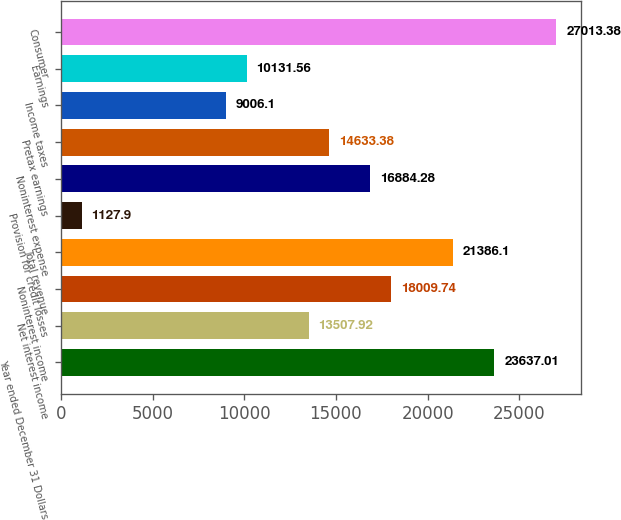Convert chart. <chart><loc_0><loc_0><loc_500><loc_500><bar_chart><fcel>Year ended December 31 Dollars<fcel>Net interest income<fcel>Noninterest income<fcel>Total revenue<fcel>Provision for credit losses<fcel>Noninterest expense<fcel>Pretax earnings<fcel>Income taxes<fcel>Earnings<fcel>Consumer<nl><fcel>23637<fcel>13507.9<fcel>18009.7<fcel>21386.1<fcel>1127.9<fcel>16884.3<fcel>14633.4<fcel>9006.1<fcel>10131.6<fcel>27013.4<nl></chart> 